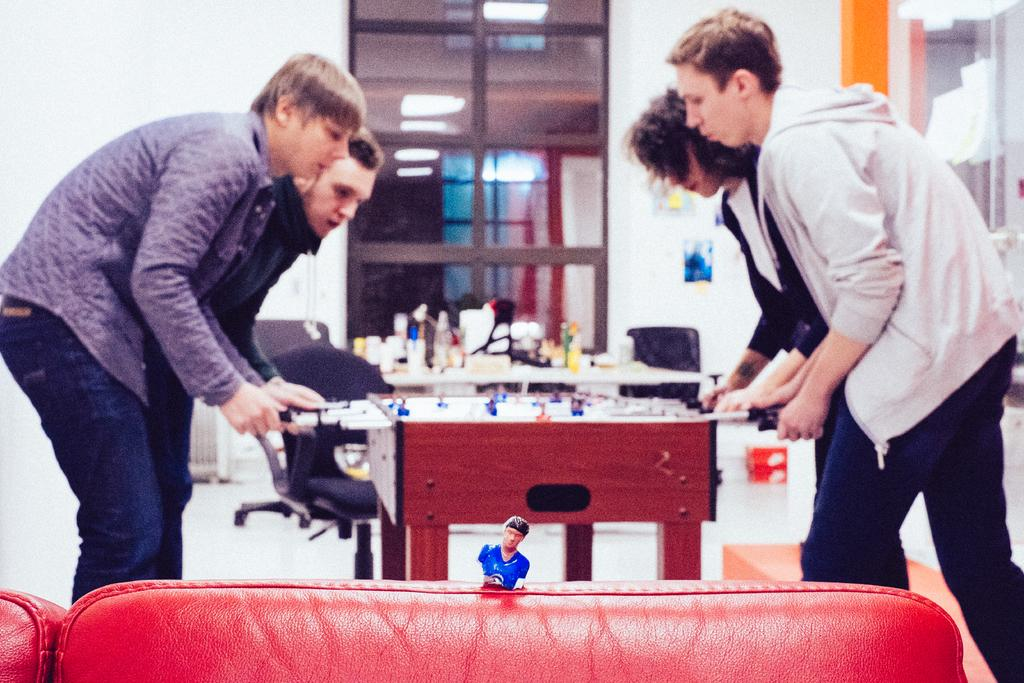What activity are the four persons engaged in within the image? The four persons are playing Foosball in the image. What piece of furniture is present in the image? There is a couch in the image. What object is placed on the couch? There is a toy on the couch. What can be seen in the background of the image? There is a window and a wall in the background of the image. What type of government is depicted in the image? There is no depiction of a government in the image; it features four persons playing Foosball, a couch, a toy, a window, and a wall. How many fingers are visible on the toy in the image? The image does not provide enough detail to determine the number of fingers on the toy, as it is not the focus of the image. 